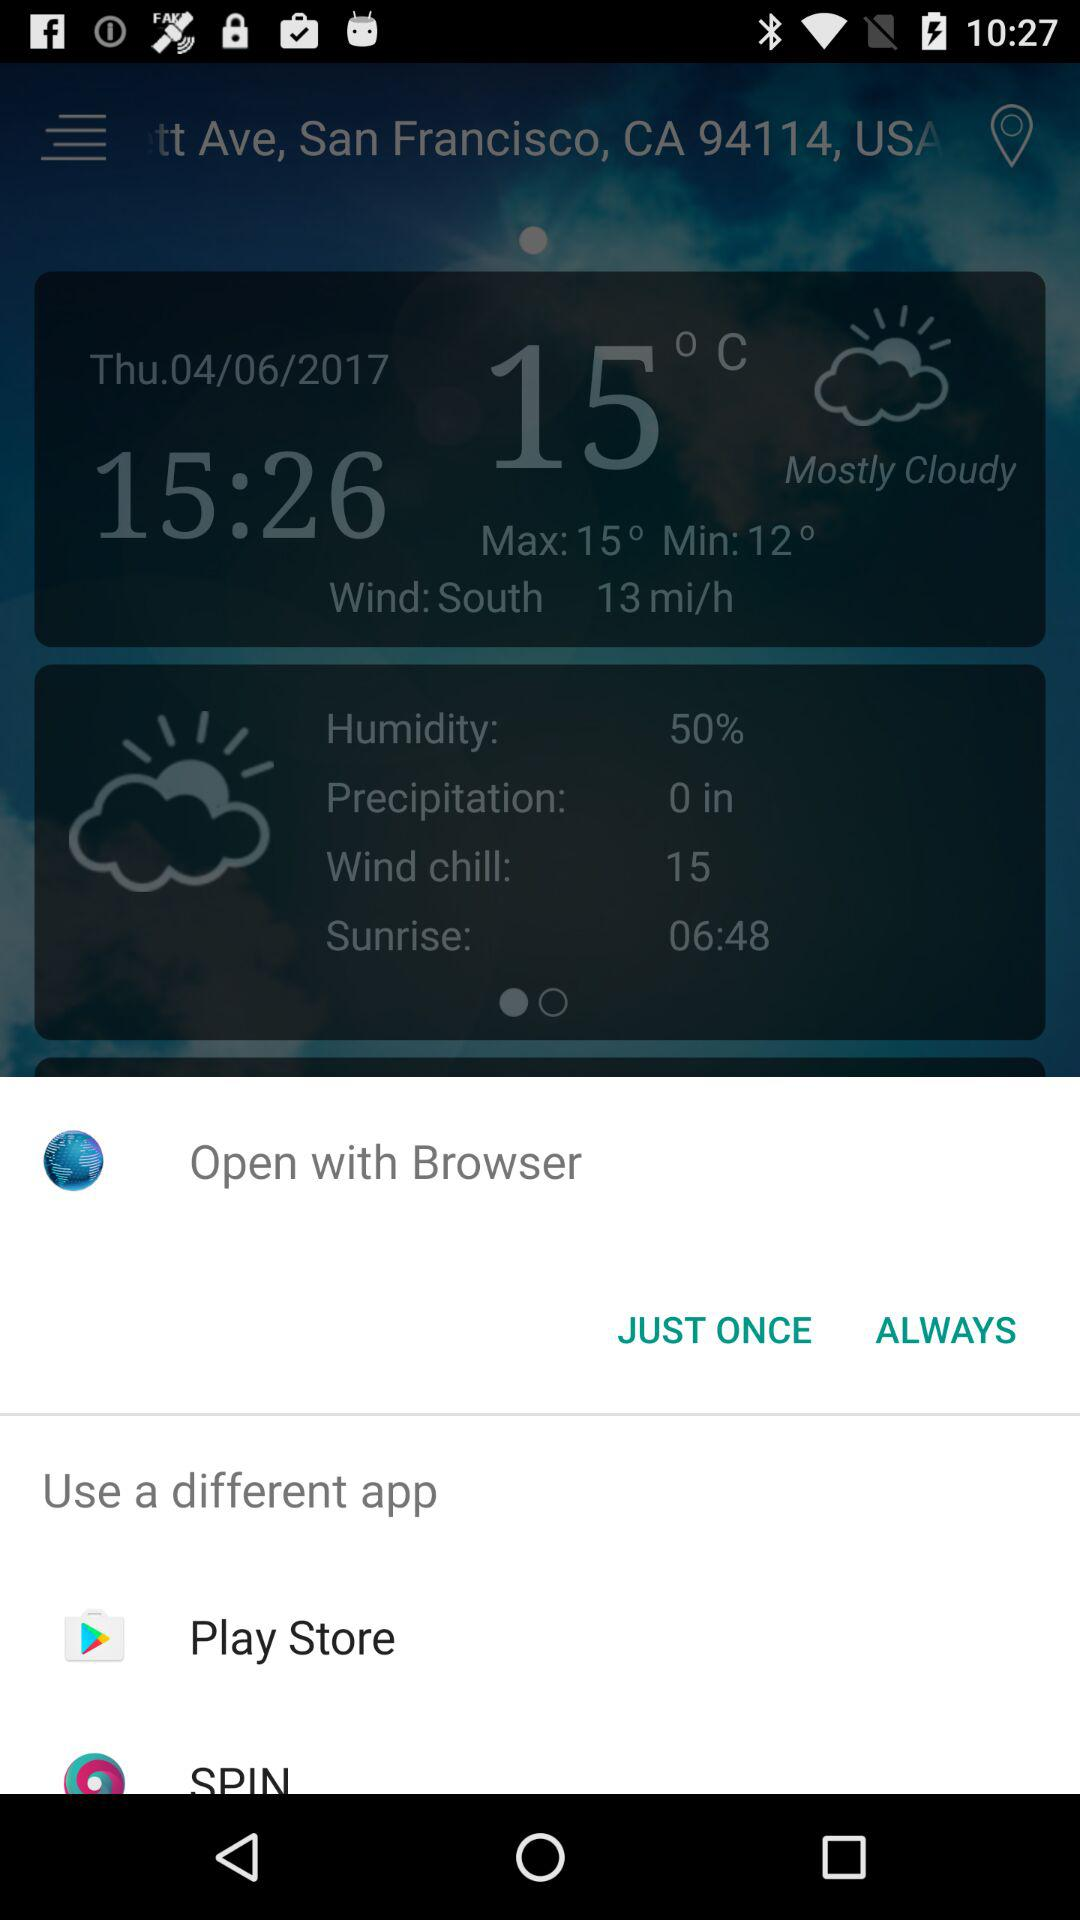What are the different apps I can use? You can use "Play Store" and "SPIN". 